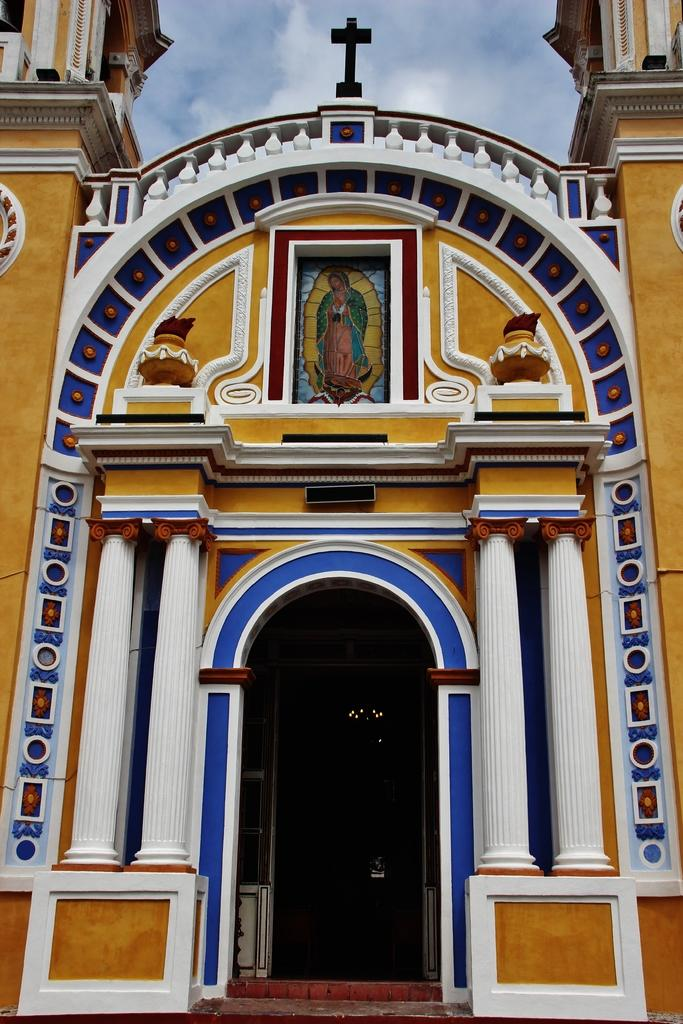What type of building is in the image? There is a church in the image. What is visible at the top of the image? The sky is visible at the top of the image. What type of powder is being used to clean the church in the image? There is no indication of any cleaning or powder in the image; it simply shows a church with the sky visible at the top. 